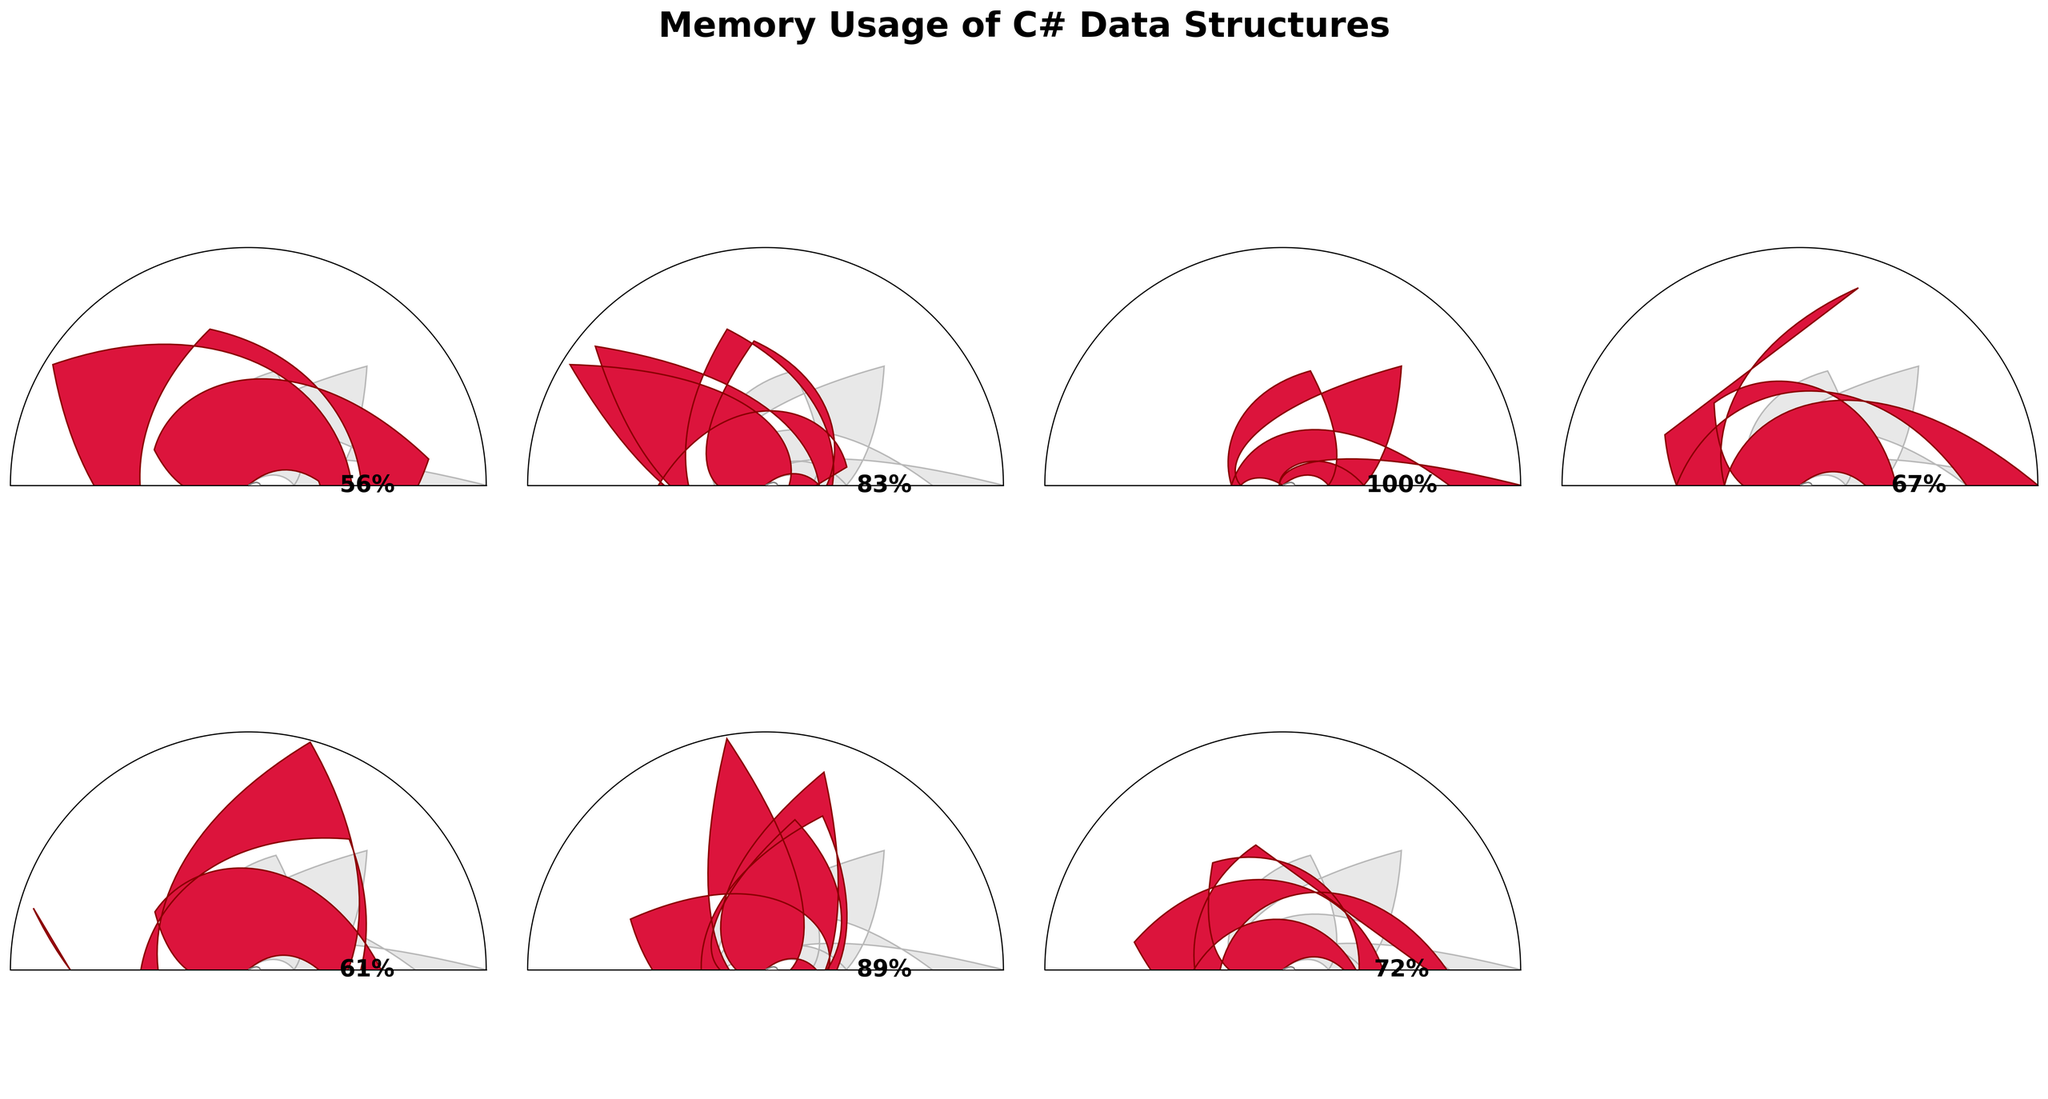What is the title of the figure? The title is displayed at the top center of the figure and reads "Memory Usage of C# Data Structures".
Answer: Memory Usage of C# Data Structures Which data structure has the highest memory usage? The figure shows each gauge chart with memory usage labeled below the data structure. The data structure with the highest memory usage is labeled "HashSet<T>" with 180 KB.
Answer: HashSet<T> How does the memory usage of the 'Queue<T>' compare to the 'Stack<T>'? Compare the labeled memory usage below each data structure. 'Queue<T>' is labeled with 120 KB, and 'Stack<T>' is labeled with 110 KB.
Answer: Queue<T> uses 10 KB more memory than Stack<T> What is the average memory usage of all the data structures? To find the average, sum all the memory usage values and divide by the number of data structures. Sum = 100 + 150 + 180 + 120 + 110 + 160 + 130 = 950 KB. Number of data structures = 7. Average = 950 KB / 7 ≈ 135.7 KB.
Answer: 135.7 KB Which data structure has a memory usage closest to the average memory usage? The average was previously calculated as 135.7 KB. The data structure closest to this average is 'ImmutableArray<T>' with 130 KB.
Answer: ImmutableArray<T> Which two data structures have the smallest difference in memory usage? Check the memory usage of each data structure and find the pair with the smallest difference. 'Stack<T>' with 110 KB and 'Queue<T>' with 120 KB have a difference of 10 KB.
Answer: Stack<T> and Queue<T> What percentage of the maximum memory usage does 'List<T>' use? Maximum memory usage is 180 KB from 'HashSet<T>'. 'List<T>' uses 150 KB. Percentage = (150/180) * 100 ≈ 83.3%.
Answer: 83.3% Is the memory usage of 'LinkedList<T>' higher than the average memory usage? The average memory usage was calculated as 135.7 KB. 'LinkedList<T>' uses 160 KB, which is higher than the average.
Answer: Yes Identify one feature that helps immediately distinguish the data structure with the highest memory usage. 'HashSet<T>' uses the most memory at 180 KB, indicated by the highest gauge value (90 degrees, crimson color reaching the farthest on the gauge).
Answer: Highest gauge value 